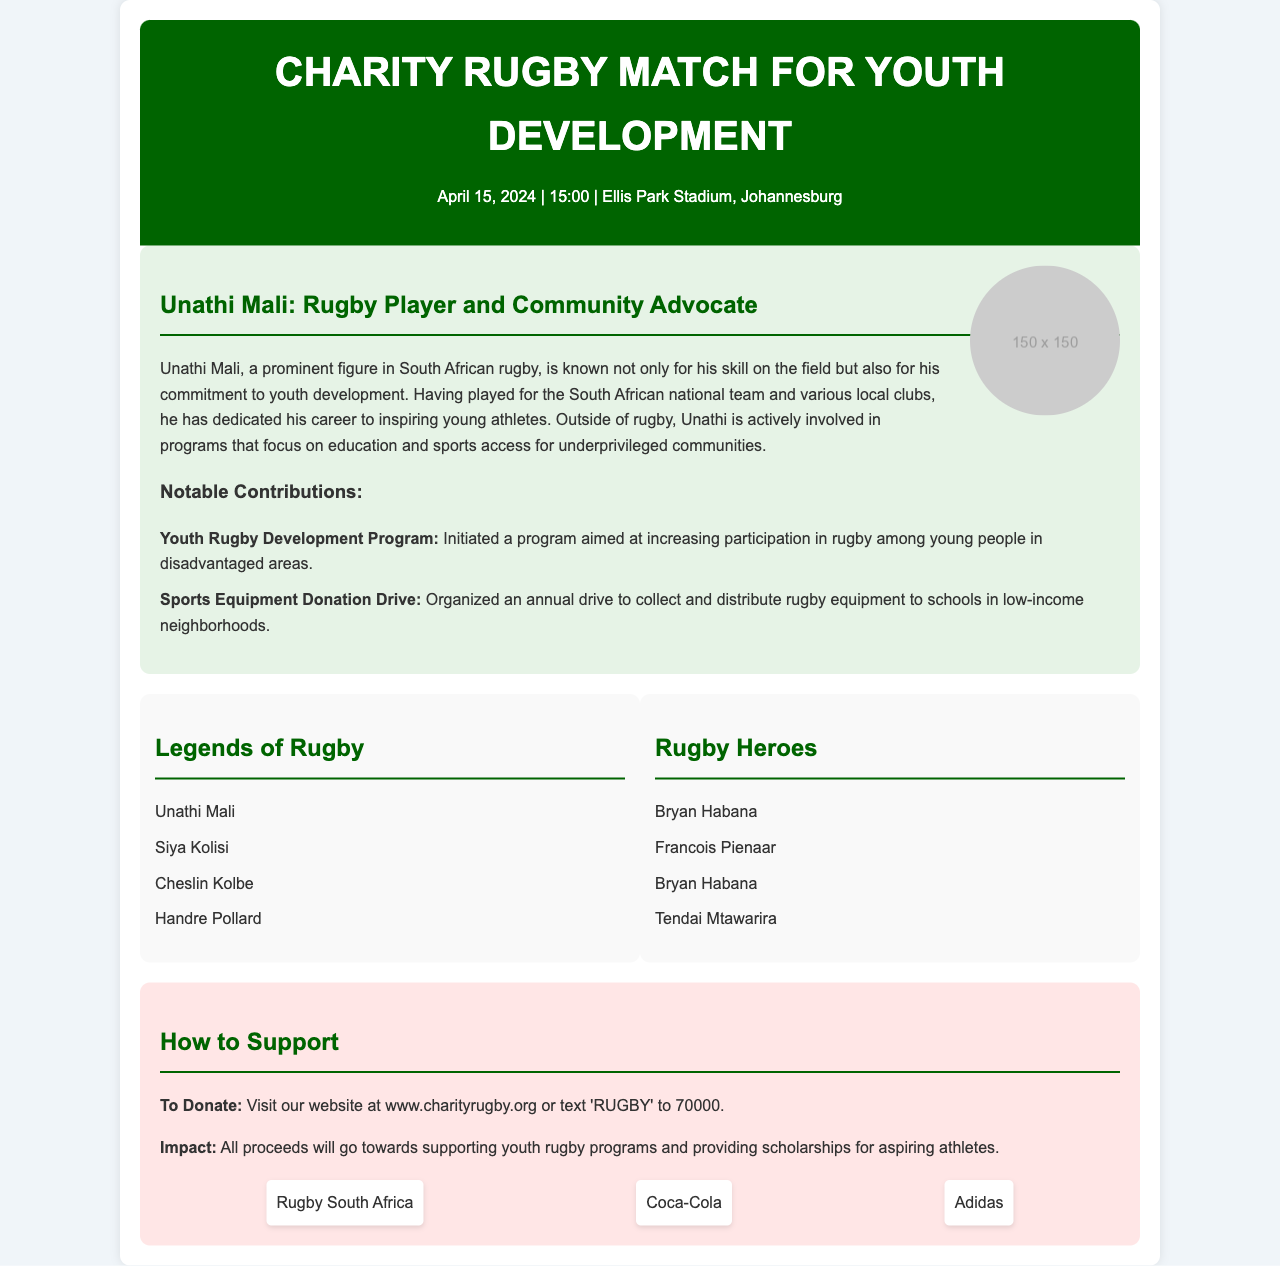What is the date of the charity match? The date of the charity match is explicitly mentioned in the event header.
Answer: April 15, 2024 What is Unathi Mali's role aside from being a rugby player? The document describes Unathi Mali's active involvement in community programs focusing on youth development and education.
Answer: Community Advocate What teams are playing in the match? The document lists the participating teams along with their names.
Answer: Legends of Rugby and Rugby Heroes Who is the captain of the team "Legends of Rugby"? The team roster includes Unathi Mali, who is a prominent player and likely the captain as referenced in the document.
Answer: Unathi Mali How can someone donate to support the charity? The document provides specific instructions on how to contribute to the charity.
Answer: Visit our website at www.charityrugby.org or text 'RUGBY' to 70000 What is one notable contribution of Unathi Mali? The document highlights specific contributions made by Unathi Mali towards youth rugby development.
Answer: Youth Rugby Development Program What is the location of the charity match? The venue for the event is mentioned in the header of the document.
Answer: Ellis Park Stadium, Johannesburg What organization is a sponsor for the charity match? Several organizations are listed as sponsors of the event in the donation section.
Answer: Rugby South Africa How many players are listed on the "Rugby Heroes" team? The roster for the Rugby Heroes team includes four players.
Answer: Four players 